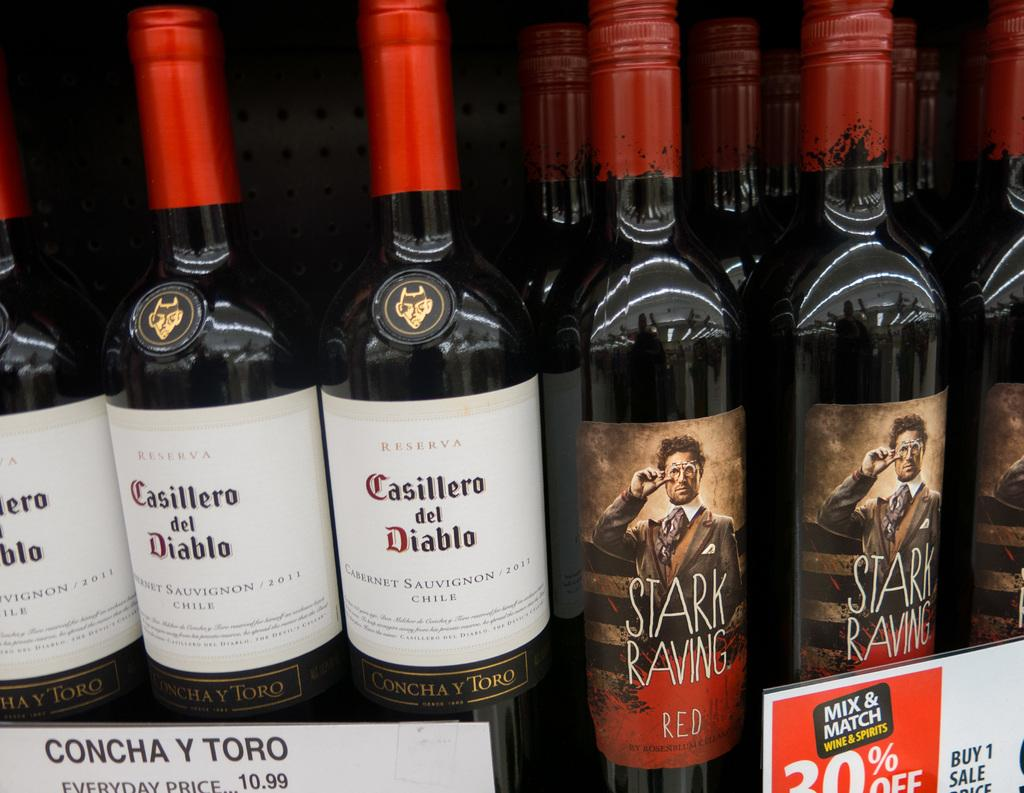<image>
Render a clear and concise summary of the photo. The Casillero del Diablo cabernet sauvignon wine bottles are right next to the Stark Raving red wine bottles. 